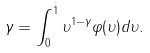<formula> <loc_0><loc_0><loc_500><loc_500>\gamma = \int _ { 0 } ^ { 1 } \upsilon ^ { 1 - \gamma } \varphi ( \upsilon ) d \upsilon .</formula> 